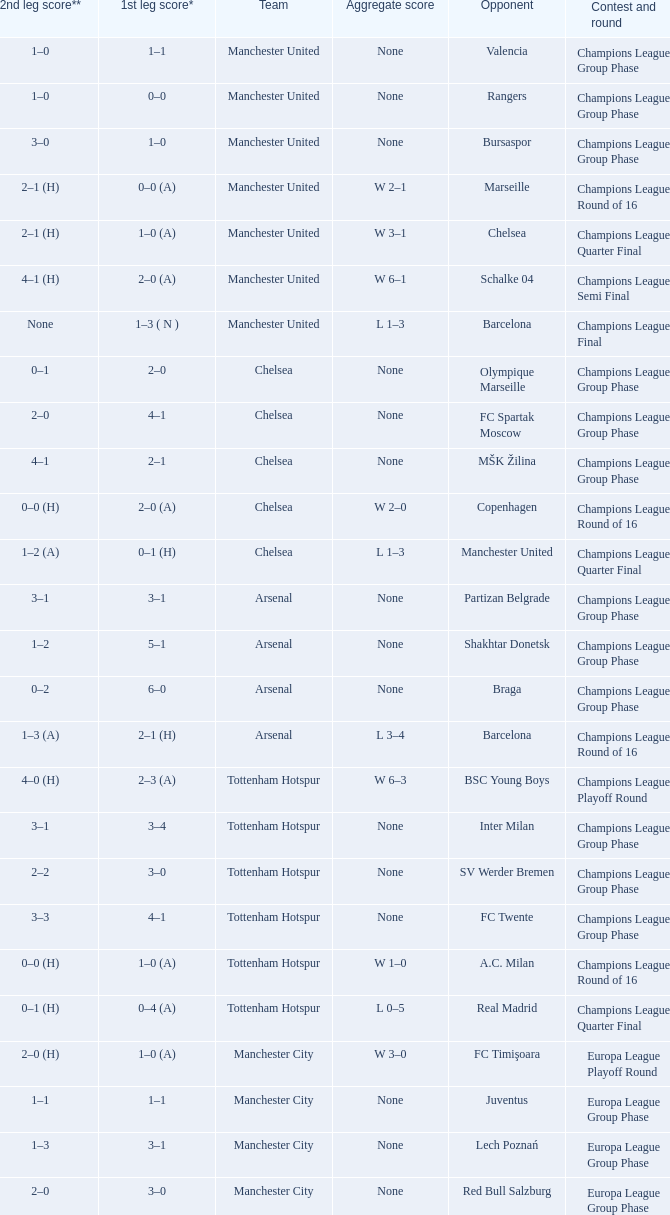What was the number of goals scored by each team in the first leg of the confrontation between liverpool and steaua bucureşti? 4–1. Parse the full table. {'header': ['2nd leg score**', '1st leg score*', 'Team', 'Aggregate score', 'Opponent', 'Contest and round'], 'rows': [['1–0', '1–1', 'Manchester United', 'None', 'Valencia', 'Champions League Group Phase'], ['1–0', '0–0', 'Manchester United', 'None', 'Rangers', 'Champions League Group Phase'], ['3–0', '1–0', 'Manchester United', 'None', 'Bursaspor', 'Champions League Group Phase'], ['2–1 (H)', '0–0 (A)', 'Manchester United', 'W 2–1', 'Marseille', 'Champions League Round of 16'], ['2–1 (H)', '1–0 (A)', 'Manchester United', 'W 3–1', 'Chelsea', 'Champions League Quarter Final'], ['4–1 (H)', '2–0 (A)', 'Manchester United', 'W 6–1', 'Schalke 04', 'Champions League Semi Final'], ['None', '1–3 ( N )', 'Manchester United', 'L 1–3', 'Barcelona', 'Champions League Final'], ['0–1', '2–0', 'Chelsea', 'None', 'Olympique Marseille', 'Champions League Group Phase'], ['2–0', '4–1', 'Chelsea', 'None', 'FC Spartak Moscow', 'Champions League Group Phase'], ['4–1', '2–1', 'Chelsea', 'None', 'MŠK Žilina', 'Champions League Group Phase'], ['0–0 (H)', '2–0 (A)', 'Chelsea', 'W 2–0', 'Copenhagen', 'Champions League Round of 16'], ['1–2 (A)', '0–1 (H)', 'Chelsea', 'L 1–3', 'Manchester United', 'Champions League Quarter Final'], ['3–1', '3–1', 'Arsenal', 'None', 'Partizan Belgrade', 'Champions League Group Phase'], ['1–2', '5–1', 'Arsenal', 'None', 'Shakhtar Donetsk', 'Champions League Group Phase'], ['0–2', '6–0', 'Arsenal', 'None', 'Braga', 'Champions League Group Phase'], ['1–3 (A)', '2–1 (H)', 'Arsenal', 'L 3–4', 'Barcelona', 'Champions League Round of 16'], ['4–0 (H)', '2–3 (A)', 'Tottenham Hotspur', 'W 6–3', 'BSC Young Boys', 'Champions League Playoff Round'], ['3–1', '3–4', 'Tottenham Hotspur', 'None', 'Inter Milan', 'Champions League Group Phase'], ['2–2', '3–0', 'Tottenham Hotspur', 'None', 'SV Werder Bremen', 'Champions League Group Phase'], ['3–3', '4–1', 'Tottenham Hotspur', 'None', 'FC Twente', 'Champions League Group Phase'], ['0–0 (H)', '1–0 (A)', 'Tottenham Hotspur', 'W 1–0', 'A.C. Milan', 'Champions League Round of 16'], ['0–1 (H)', '0–4 (A)', 'Tottenham Hotspur', 'L 0–5', 'Real Madrid', 'Champions League Quarter Final'], ['2–0 (H)', '1–0 (A)', 'Manchester City', 'W 3–0', 'FC Timişoara', 'Europa League Playoff Round'], ['1–1', '1–1', 'Manchester City', 'None', 'Juventus', 'Europa League Group Phase'], ['1–3', '3–1', 'Manchester City', 'None', 'Lech Poznań', 'Europa League Group Phase'], ['2–0', '3–0', 'Manchester City', 'None', 'Red Bull Salzburg', 'Europa League Group Phase'], ['3–0 (H)', '0–0 (A)', 'Manchester City', 'W 3–0', 'Aris', 'Europa League Round of 32'], ['1–0 (H)', '0–2 (A)', 'Manchester City', 'L 1–2', 'Dynamio Kyiv', 'Europa League Round of 16'], ['2–3 (H)', '1–1 (A)', 'Aston Villa', 'L 3–4', 'SK Rapid Wien', 'Europa League Playoff Round'], ['2–0 (H)', '2–0 (A)', 'Liverpool', 'W 4–0', 'FK Rabotnički', 'Europa League 3rd Qual. Round'], ['2–1 (A)', '1–0 (H)', 'Liverpool', 'W 3–1', 'Trabzonspor', 'Europa League Playoff Round'], ['0–0', '3–1', 'Liverpool', 'None', 'Napoli', 'Europa League Group Phase'], ['1–1', '4–1', 'Liverpool', 'None', 'Steaua Bucureşti', 'Europa League Group Phase'], ['0–0', '0–0', 'Liverpool', 'None', 'Utrecht', 'Europa League Group Phase'], ['1–0 (H)', '0–0 (A)', 'Liverpool', 'W 1–0', 'Sparta Prague', 'Europa League Round of 32']]} 